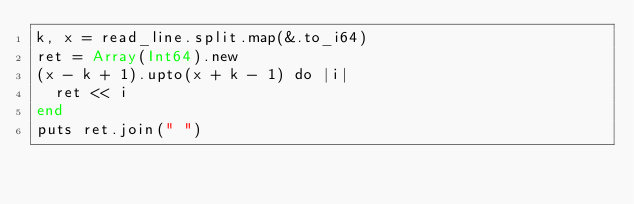<code> <loc_0><loc_0><loc_500><loc_500><_Crystal_>k, x = read_line.split.map(&.to_i64)
ret = Array(Int64).new
(x - k + 1).upto(x + k - 1) do |i|
  ret << i
end
puts ret.join(" ")
</code> 